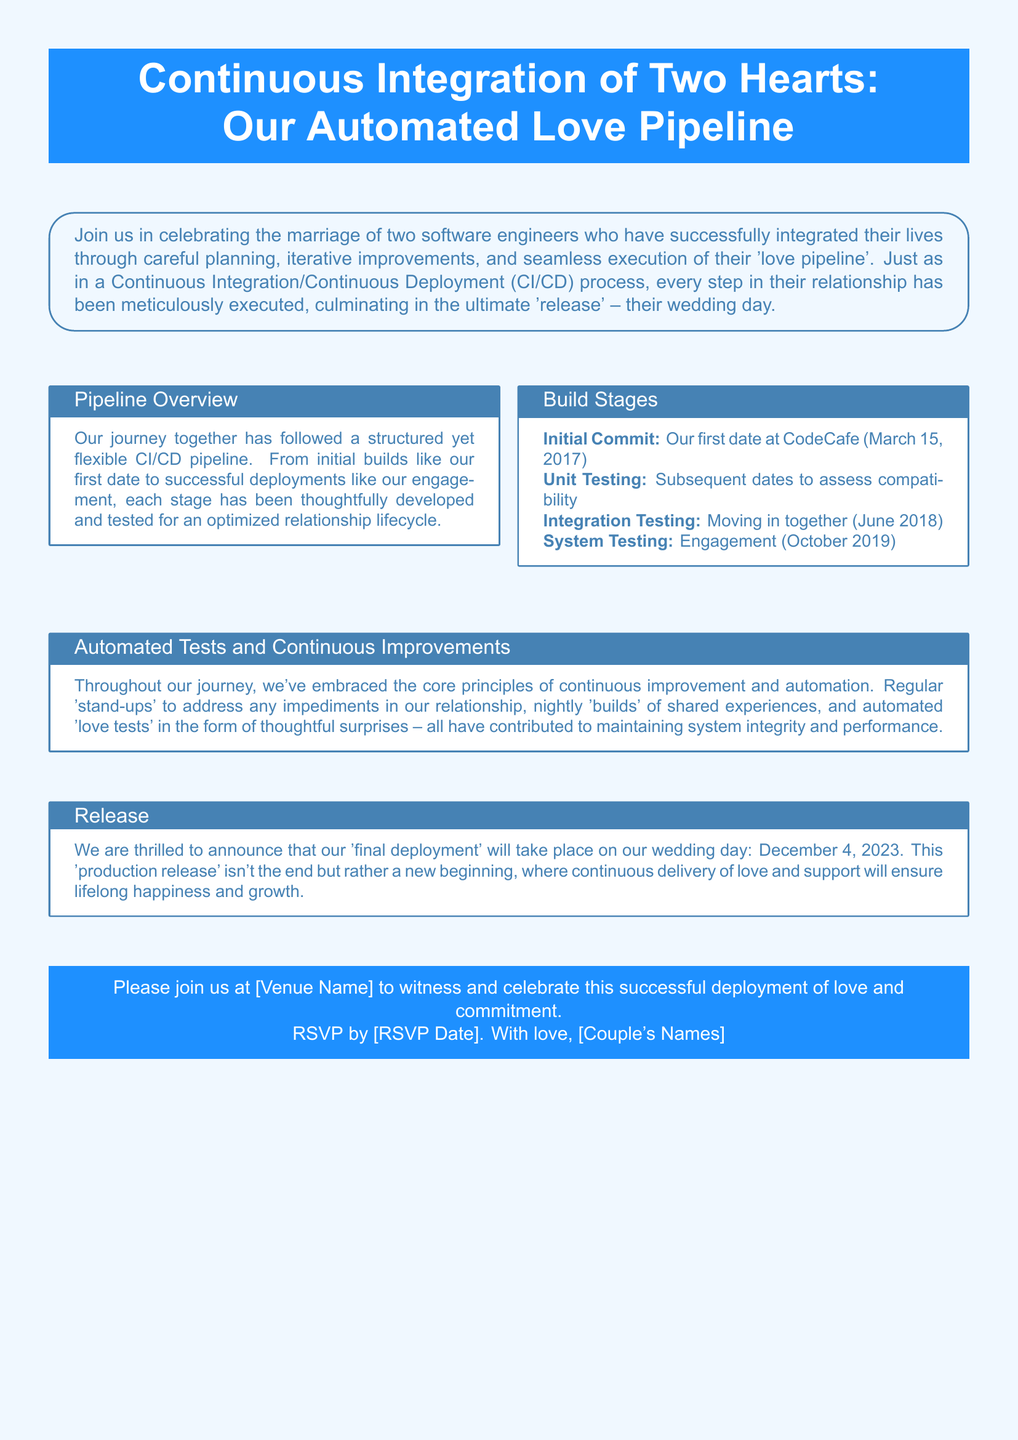What is the title of the invitation? The title of the invitation is stated in the box at the top of the document.
Answer: Continuous Integration of Two Hearts: Our Automated Love Pipeline What is the date of the wedding? The wedding date is mentioned in the "Release" section of the document.
Answer: December 4, 2023 Where did the first date take place? The location of the first date is provided in the "Build Stages" section.
Answer: CodeCafe What is the purpose of the invitation? The document describes the overall objective in the first tcolorbox on the page.
Answer: Celebrate the marriage What was one of the initial builds in their relationship? The "Build Stages" section lists various stages of their relationship.
Answer: Our first date at CodeCafe What will continue after the wedding day? The document mentions the future after the wedding in the final tcolorbox.
Answer: Continuous delivery of love and support What type of professionals are the couple? This information is noted in the introduction to the invitation.
Answer: Software engineers What is referred to as the 'final deployment'? The document identifies a key event in the final tcolorbox.
Answer: Wedding day 